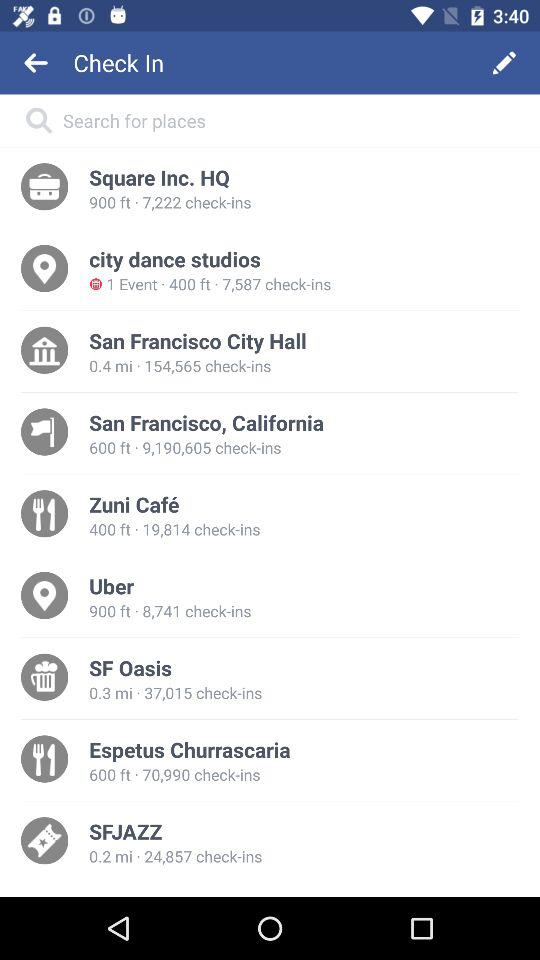How many check-ins does the venue with the most check-ins have?
Answer the question using a single word or phrase. 9,190,605 